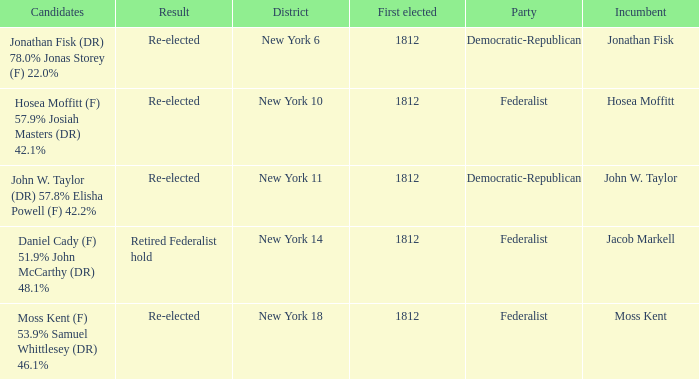Name the first elected for hosea moffitt (f) 57.9% josiah masters (dr) 42.1% 1812.0. 